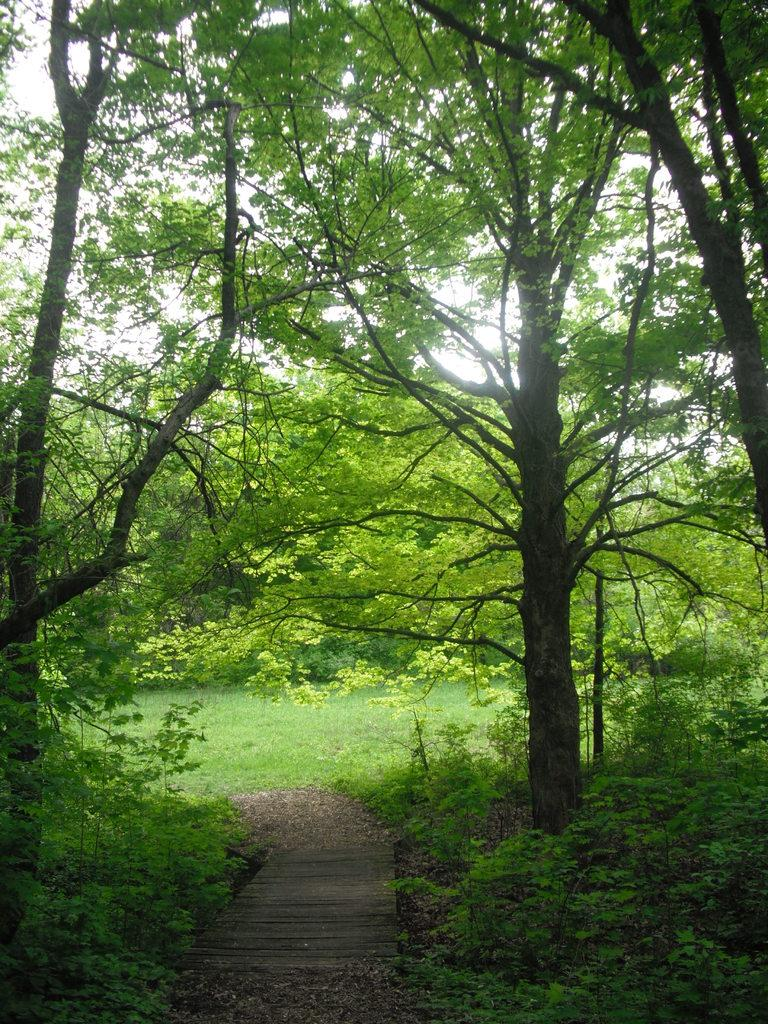What type of surface is visible in the image? There is a wooden path in the image. What type of vegetation is present in the image? There is grass, plants, and trees in the image. What is visible in the sky in the image? The sky is visible in the image. What type of wheel can be seen in the image? There is no wheel present in the image. Is the image set in space? No, the image is not set in space; it features a wooden path, grass, plants, trees, and the sky. What type of fuel is being used by the plants in the image? The image does not provide information about the type of fuel used by the plants; it simply shows their presence. 